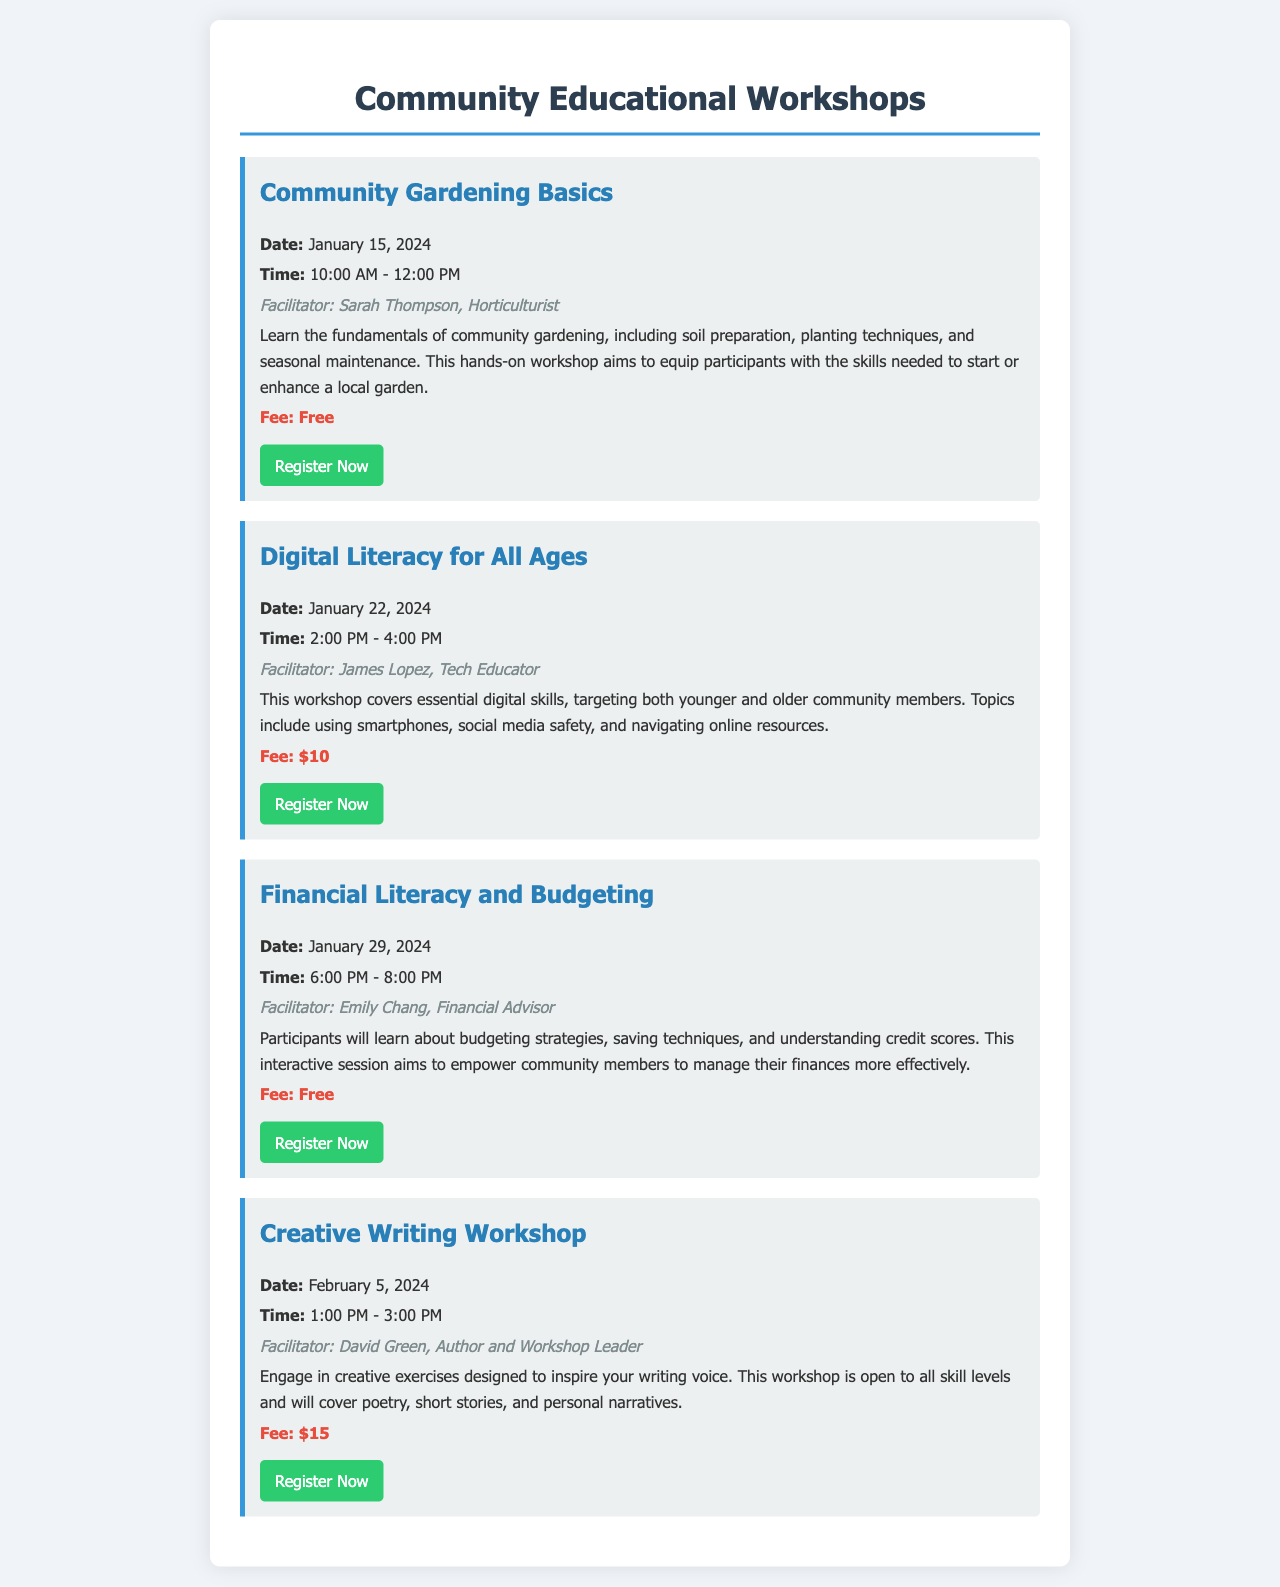What is the date of the Community Gardening Basics workshop? The date is provided in the workshop description section, which states it will be held on January 15, 2024.
Answer: January 15, 2024 Who is the facilitator for the Digital Literacy for All Ages workshop? The facilitator's name is mentioned in the session description, specifically stating James Lopez as the tech educator.
Answer: James Lopez What is the fee for the Creative Writing Workshop? The fee is stated clearly under the workshop details, indicating that the cost is $15.
Answer: $15 How many workshops are free of charge? By examining the fees listed in the workshops, two sessions clearly indicate a cost of free.
Answer: 2 What time does the Financial Literacy and Budgeting workshop begin? The start time is found within the workshop details, where it specifies that it begins at 6:00 PM.
Answer: 6:00 PM What types of skills will be covered in the Digital Literacy for All Ages workshop? The description mentions that essential digital skills like using smartphones and social media safety will be covered.
Answer: Digital skills Which workshop takes place on February 5, 2024? The date is specified in the title and details of the workshop, mentioning the Creative Writing Workshop.
Answer: Creative Writing Workshop How long is the Community Gardening Basics workshop? The duration is indicated in the workshop details as 2 hours, from 10:00 AM to 12:00 PM.
Answer: 2 hours 